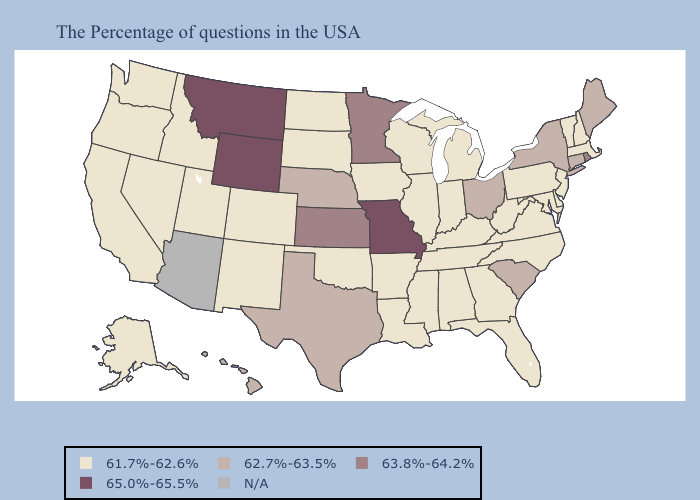Name the states that have a value in the range 61.7%-62.6%?
Quick response, please. Massachusetts, New Hampshire, Vermont, New Jersey, Delaware, Maryland, Pennsylvania, Virginia, North Carolina, West Virginia, Florida, Georgia, Michigan, Kentucky, Indiana, Alabama, Tennessee, Wisconsin, Illinois, Mississippi, Louisiana, Arkansas, Iowa, Oklahoma, South Dakota, North Dakota, Colorado, New Mexico, Utah, Idaho, Nevada, California, Washington, Oregon, Alaska. Which states have the lowest value in the USA?
Concise answer only. Massachusetts, New Hampshire, Vermont, New Jersey, Delaware, Maryland, Pennsylvania, Virginia, North Carolina, West Virginia, Florida, Georgia, Michigan, Kentucky, Indiana, Alabama, Tennessee, Wisconsin, Illinois, Mississippi, Louisiana, Arkansas, Iowa, Oklahoma, South Dakota, North Dakota, Colorado, New Mexico, Utah, Idaho, Nevada, California, Washington, Oregon, Alaska. Name the states that have a value in the range N/A?
Answer briefly. Arizona. What is the value of Georgia?
Short answer required. 61.7%-62.6%. Which states have the highest value in the USA?
Short answer required. Missouri, Wyoming, Montana. Is the legend a continuous bar?
Keep it brief. No. Name the states that have a value in the range N/A?
Keep it brief. Arizona. Is the legend a continuous bar?
Write a very short answer. No. Does Alaska have the lowest value in the USA?
Quick response, please. Yes. Does Wyoming have the highest value in the USA?
Write a very short answer. Yes. What is the lowest value in the USA?
Keep it brief. 61.7%-62.6%. Name the states that have a value in the range 63.8%-64.2%?
Concise answer only. Rhode Island, Minnesota, Kansas. What is the lowest value in states that border New Mexico?
Quick response, please. 61.7%-62.6%. Which states have the highest value in the USA?
Short answer required. Missouri, Wyoming, Montana. 